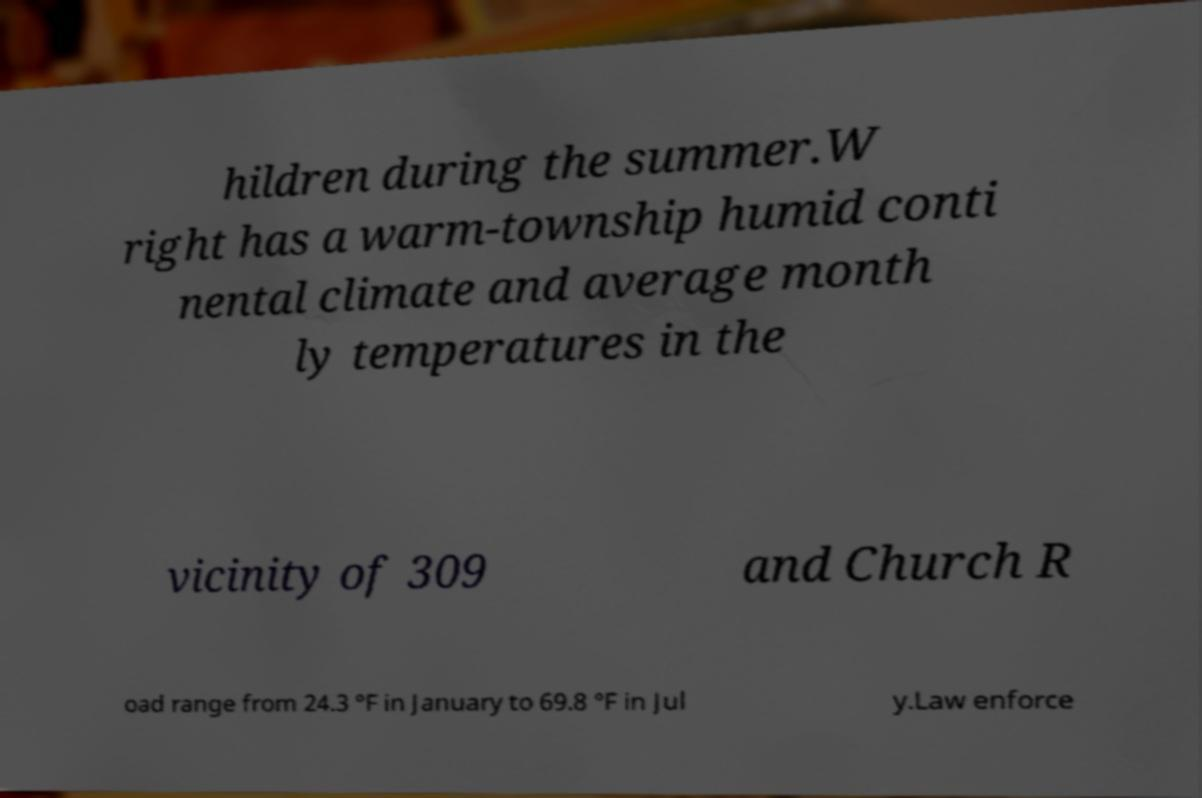Please read and relay the text visible in this image. What does it say? hildren during the summer.W right has a warm-township humid conti nental climate and average month ly temperatures in the vicinity of 309 and Church R oad range from 24.3 °F in January to 69.8 °F in Jul y.Law enforce 